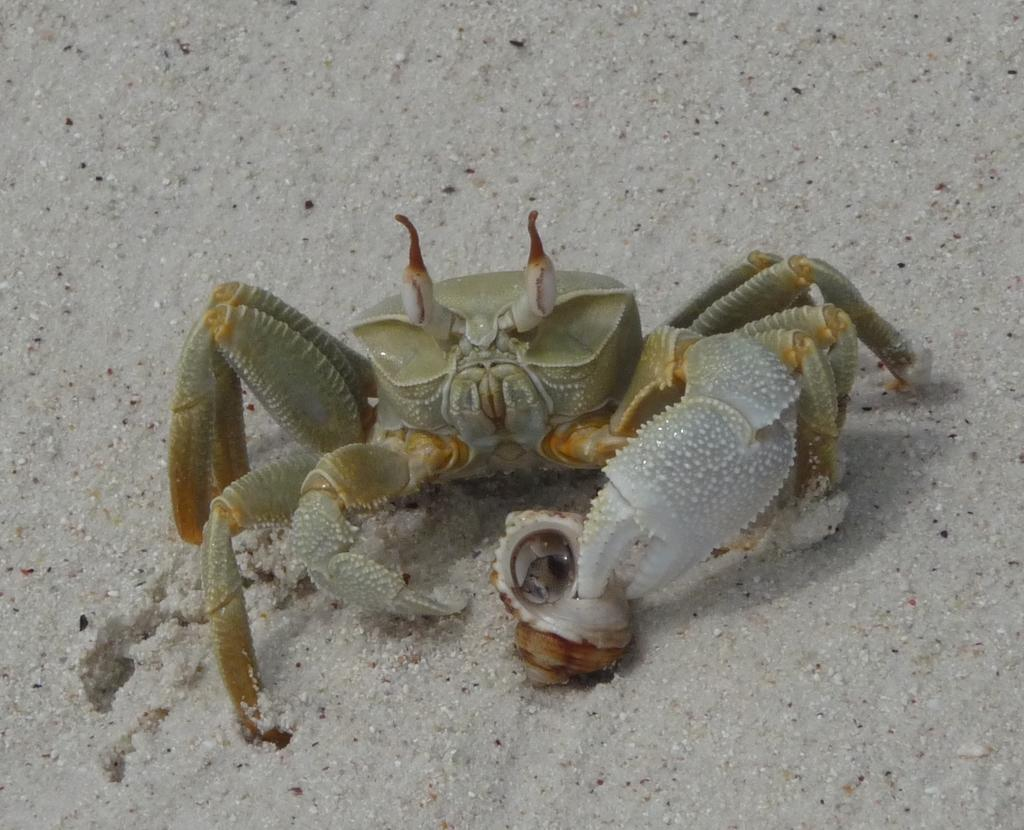What is the main subject of the picture? There is a crab in the picture. What can be seen in the background of the picture? The background of the picture contains wet sand. Where might this picture have been taken? The picture might have been taken at the seashore. What type of business is being conducted in the picture? There is no indication of any business activity in the picture; it features a crab and wet sand. How does the crab stop moving in the picture? The crab does not stop moving in the picture; it is a still image, and the crab's movement is not depicted. 